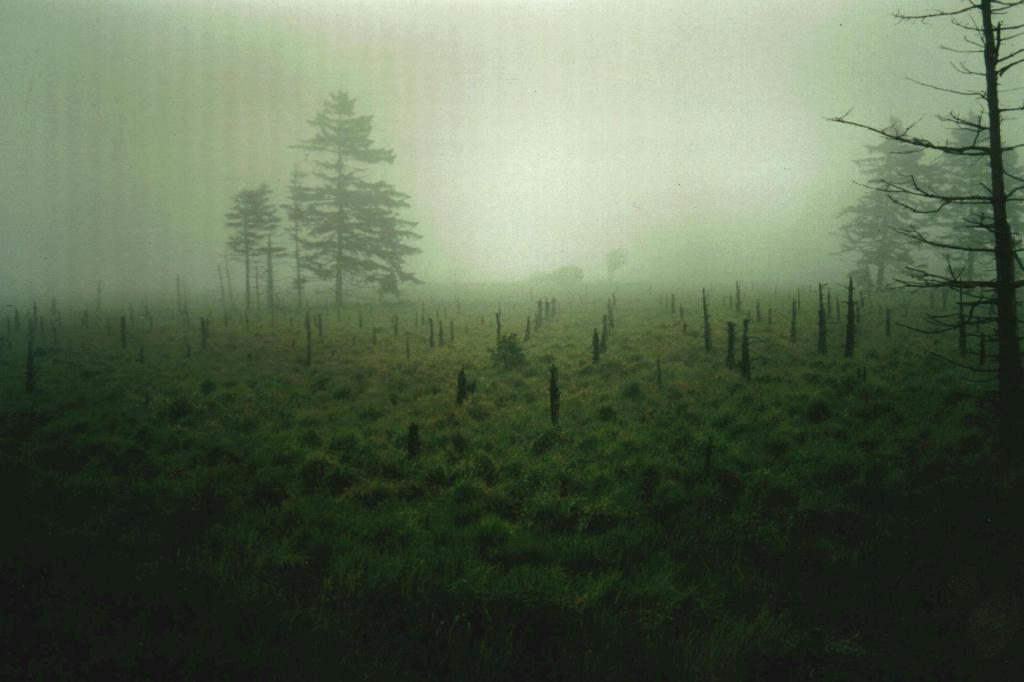What type of vegetation can be seen in the image? There is grass in the image. What objects are made of wood in the image? There are wooden sticks in the image. What type of natural structures are present in the image? There are trees in the image. What part of the natural environment is visible in the image? The sky is visible in the image. How many snakes can be seen slithering on the grass in the image? There are no snakes present in the image; it features grass, wooden sticks, trees, and the sky. What type of sticks are used for licking ice cream in the image? There are no sticks used for licking ice cream in the image; the wooden sticks are not associated with any ice cream. 